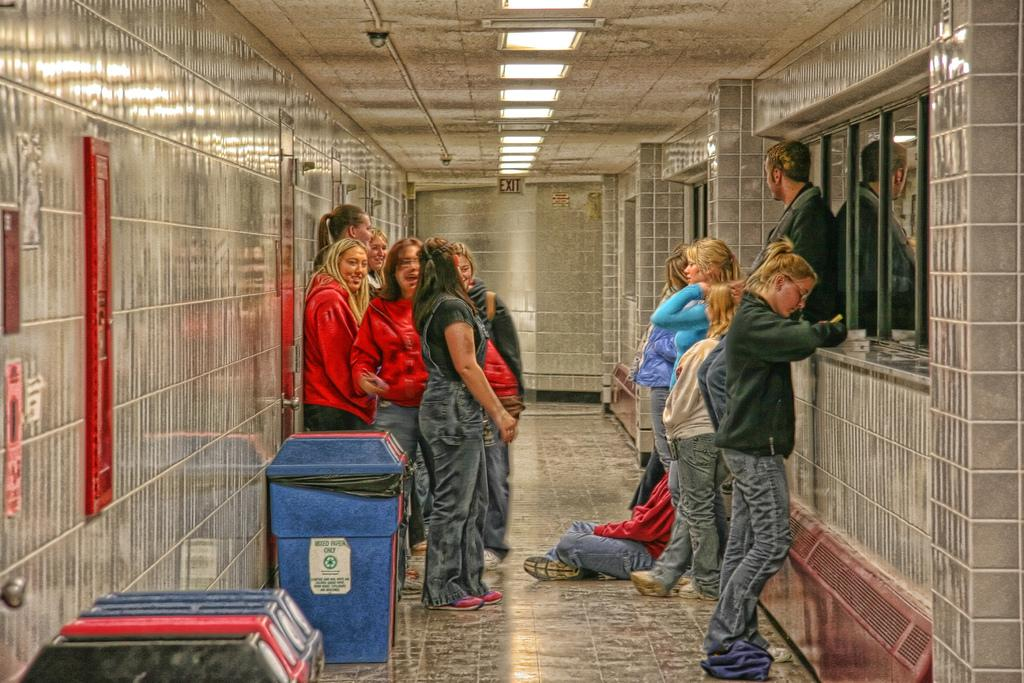What are the people in the image doing? The people in the image are standing. Is there anyone sitting in the image? Yes, there is a person sitting on the floor. What can be seen on the left side of the image? There are bins on the left side of the image. What is visible in the background of the image? There is a wall and lights visible in the background of the image. How many cats are sitting on the person's lap in the image? There are no cats present in the image. What type of nail is being used by the person sitting on the floor? There is no nail visible in the image, and no activity involving a nail is taking place. 